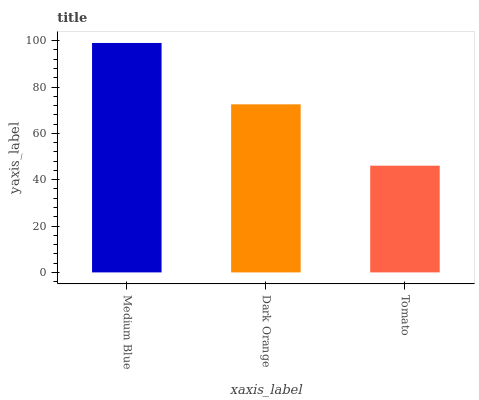Is Tomato the minimum?
Answer yes or no. Yes. Is Medium Blue the maximum?
Answer yes or no. Yes. Is Dark Orange the minimum?
Answer yes or no. No. Is Dark Orange the maximum?
Answer yes or no. No. Is Medium Blue greater than Dark Orange?
Answer yes or no. Yes. Is Dark Orange less than Medium Blue?
Answer yes or no. Yes. Is Dark Orange greater than Medium Blue?
Answer yes or no. No. Is Medium Blue less than Dark Orange?
Answer yes or no. No. Is Dark Orange the high median?
Answer yes or no. Yes. Is Dark Orange the low median?
Answer yes or no. Yes. Is Tomato the high median?
Answer yes or no. No. Is Medium Blue the low median?
Answer yes or no. No. 